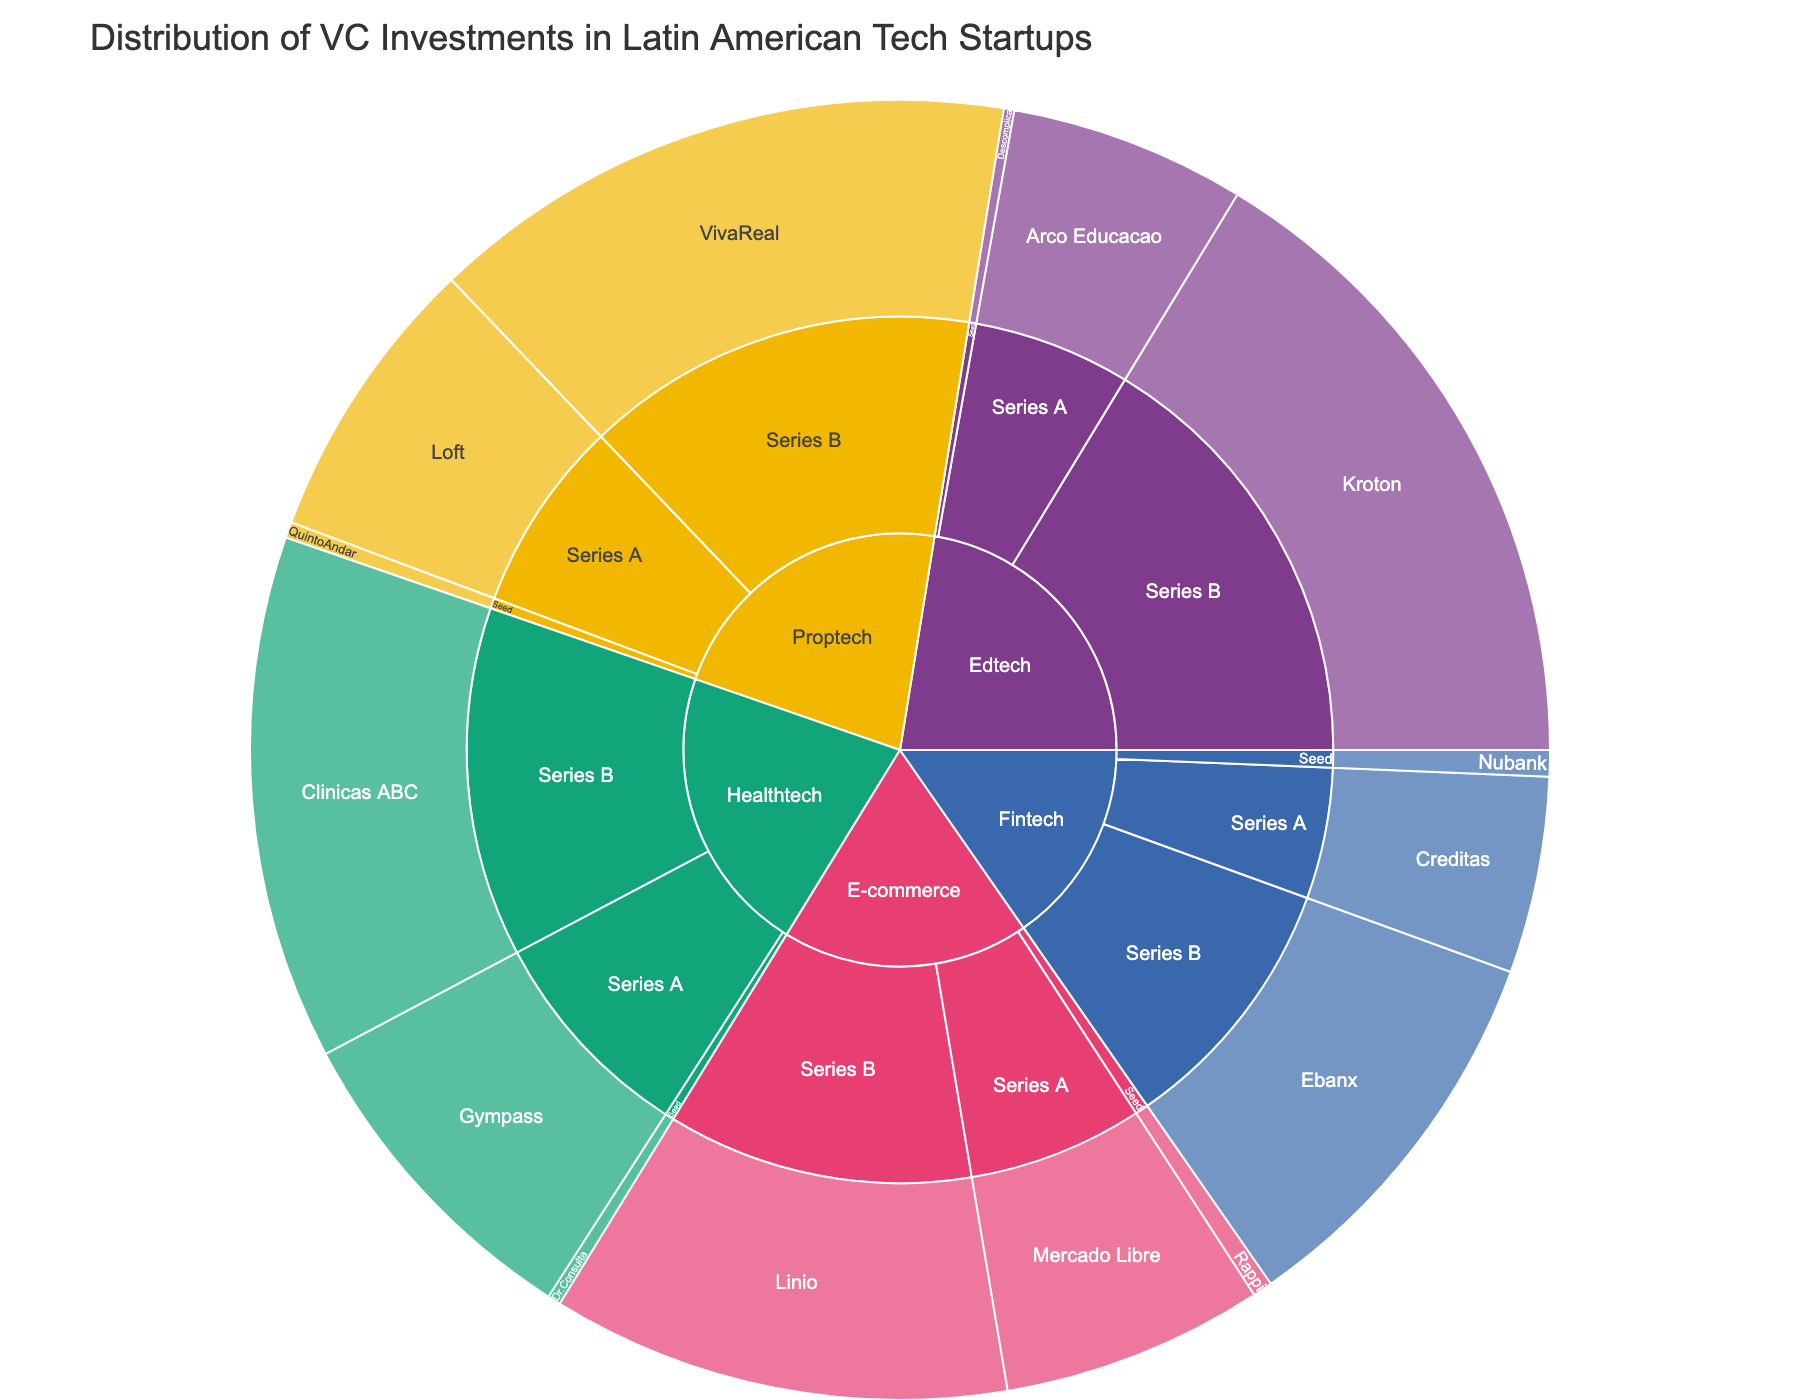What is the title of the figure? The title is typically placed at the top of the figure and provides a brief, descriptive summary of the visualization's purpose. Here, it reads: "Distribution of VC Investments in Latin American Tech Startups."
Answer: Distribution of VC Investments in Latin American Tech Startups Which industry received the highest total investment? By observing the size of the slices for each industry at the first level of the sunburst plot, you can visually assess which industry has the largest combined investment.
Answer: Proptech How much investment did Series B startups in the Fintech industry receive? Locate the "Fintech" sector at the first level, then find the Series B stage within Fintech, and finally sum the investment amount shown. Ebanx, the only Series B Fintech company, received $30,000,000.
Answer: $30,000,000 What’s the combined total investment for e-commerce startups? To find the total investment for e-commerce startups, sum all the investments in the "E-commerce" category: Seed (Rappi: $1,500,000), Series A (Mercado Libre: $20,000,000), Series B (Linio: $35,000,000). Total = $1,500,000 + $20,000,000 + $35,000,000.
Answer: $56,500,000 How many healthtech companies are shown in the figure? Identify the "Healthtech" division and count the companies listed at the third level: Dr.Consulta, Gympass, Clinicas ABC.
Answer: 3 Which funding stage in the Edtech sector received the least investment? Under the "Edtech" category, compare the investment amounts across Seed, Series A, and Series B. Seed has the smallest amount ($800,000, compared to Series A's $18,000,000 and Series B's $50,000,000).
Answer: Seed Which company received the lowest amount of investment? Look through all the segments and find the company with the smallest investment amount displayed. Descomplica, in the Edtech sector's Seed stage, received $800,000, the lowest amount in the plot.
Answer: Descomplica Among Series A companies, which one received the highest investment? Navigate the plot to the Series A level and compare investment amounts across various industries. Loft, in the Proptech sector, received $22,000,000, the highest in this group.
Answer: Loft 